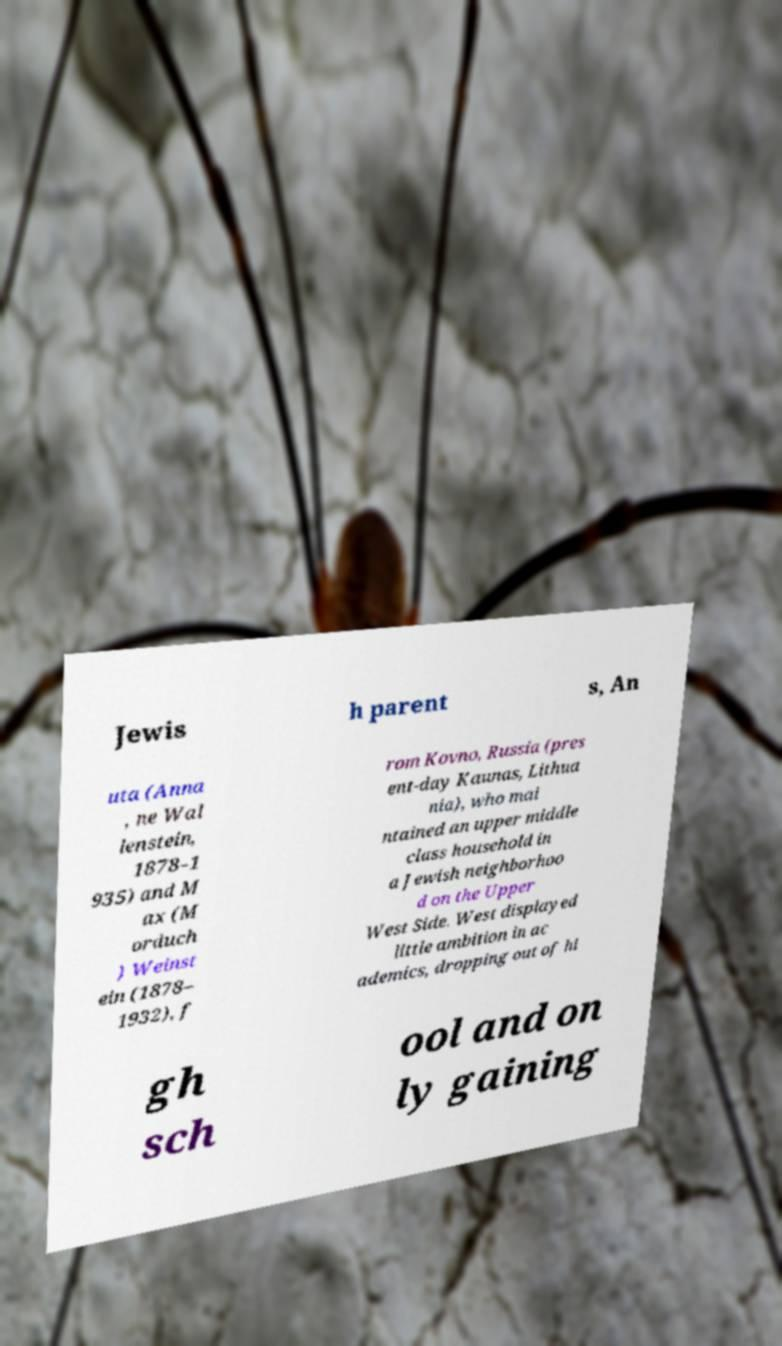For documentation purposes, I need the text within this image transcribed. Could you provide that? Jewis h parent s, An uta (Anna , ne Wal lenstein, 1878–1 935) and M ax (M orduch ) Weinst ein (1878– 1932), f rom Kovno, Russia (pres ent-day Kaunas, Lithua nia), who mai ntained an upper middle class household in a Jewish neighborhoo d on the Upper West Side. West displayed little ambition in ac ademics, dropping out of hi gh sch ool and on ly gaining 